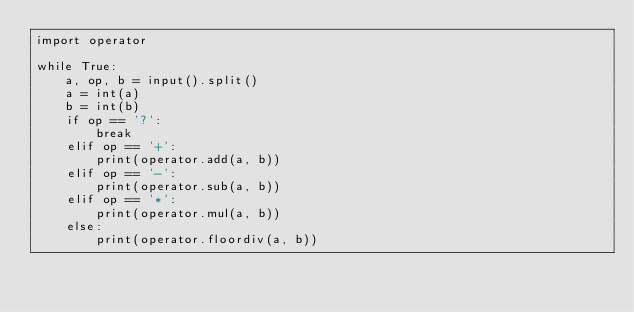Convert code to text. <code><loc_0><loc_0><loc_500><loc_500><_Python_>import operator

while True:
    a, op, b = input().split()
    a = int(a)
    b = int(b)
    if op == '?':
        break
    elif op == '+':
        print(operator.add(a, b))
    elif op == '-':
        print(operator.sub(a, b))
    elif op == '*':
        print(operator.mul(a, b))
    else:
        print(operator.floordiv(a, b))


</code> 